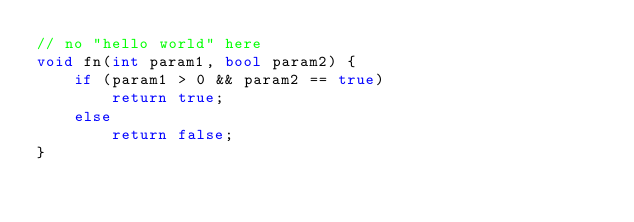<code> <loc_0><loc_0><loc_500><loc_500><_C++_>// no "hello world" here 
void fn(int param1, bool param2) {
    if (param1 > 0 && param2 == true) 
        return true;
    else
        return false;
}</code> 